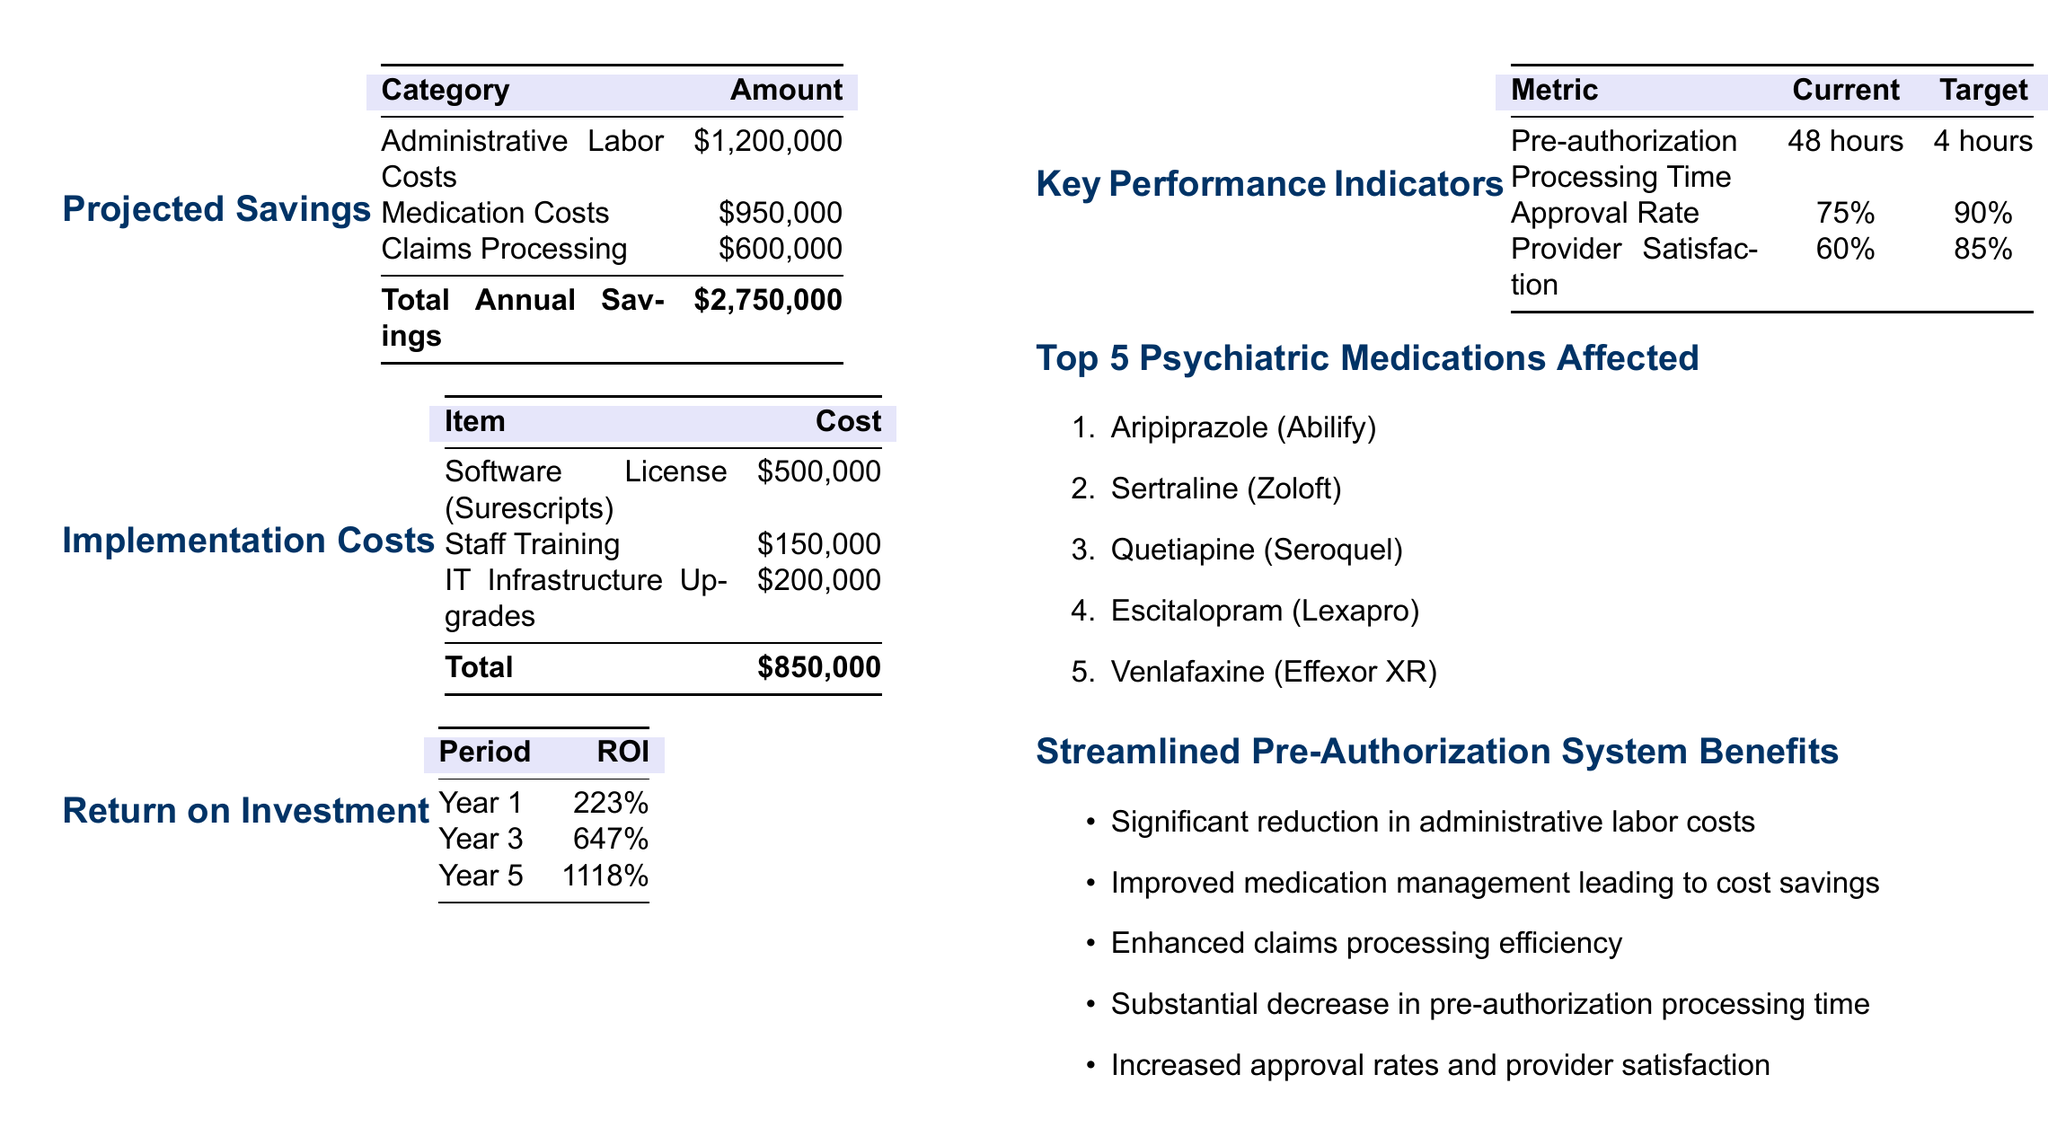What is the total annual savings? The total annual savings is mentioned at the bottom of the "Projected Savings" section as the sum of all savings categories.
Answer: $2,750,000 What are the implementation costs? The implementation costs are provided in the "Implementation Costs" section, detailing software, training, and upgrades.
Answer: $850,000 What is the ROI in Year 3? The ROI for Year 3 is listed in the "Return on Investment" table, reflecting the returns expected for that period.
Answer: 647% What is the current pre-authorization processing time? The current pre-authorization processing time is specified in the "Key Performance Indicators" section.
Answer: 48 hours Which medication is listed first in the Top 5 Psychiatric Medications Affected? The first medication in the list of top medications is highlighted in the "Top 5 Psychiatric Medications Affected" section.
Answer: Aripiprazole (Abilify) What is the target approval rate? The target approval rate is specified in the "Key Performance Indicators" as the aimed rate for better performance.
Answer: 90% What is one benefit of the streamlined pre-authorization system? One of the benefits is directly pulled from the list of advantages in the "Streamlined Pre-Authorization System Benefits".
Answer: Significant reduction in administrative labor costs What is the cost of the software license? The cost of the software license is found in the "Implementation Costs" section, under specific items.
Answer: $500,000 How many total key performance indicators are listed? The total number of key performance indicators can be counted in the "Key Performance Indicators" section.
Answer: 3 